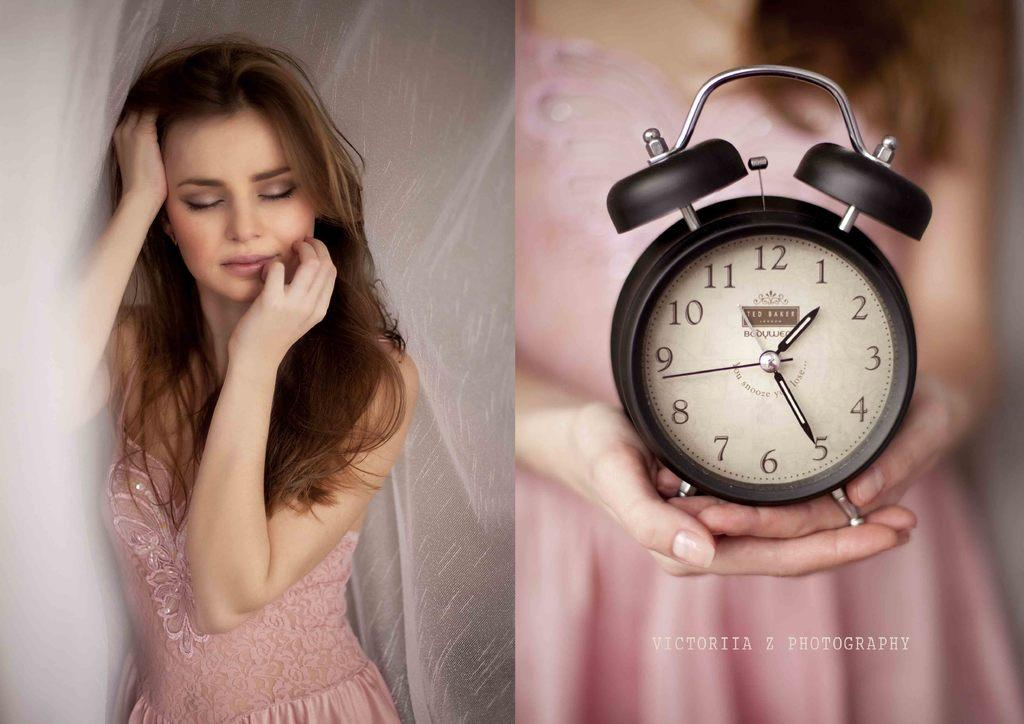Provide a one-sentence caption for the provided image. A woman is sleeping on the left side and on the right she is holding a clock showing a time of 1:25. 